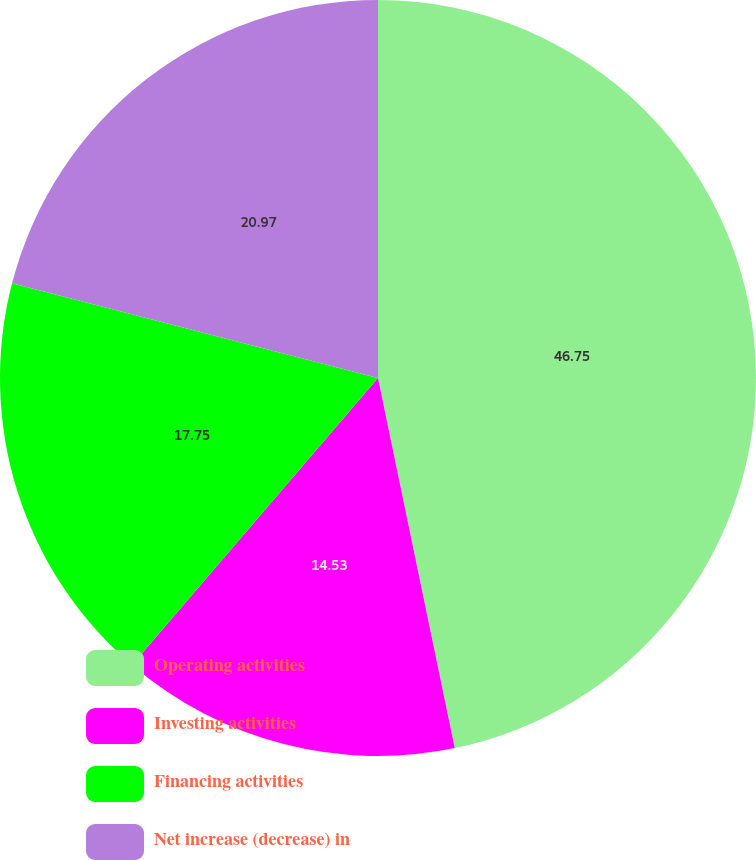Convert chart to OTSL. <chart><loc_0><loc_0><loc_500><loc_500><pie_chart><fcel>Operating activities<fcel>Investing activities<fcel>Financing activities<fcel>Net increase (decrease) in<nl><fcel>46.74%<fcel>14.53%<fcel>17.75%<fcel>20.97%<nl></chart> 